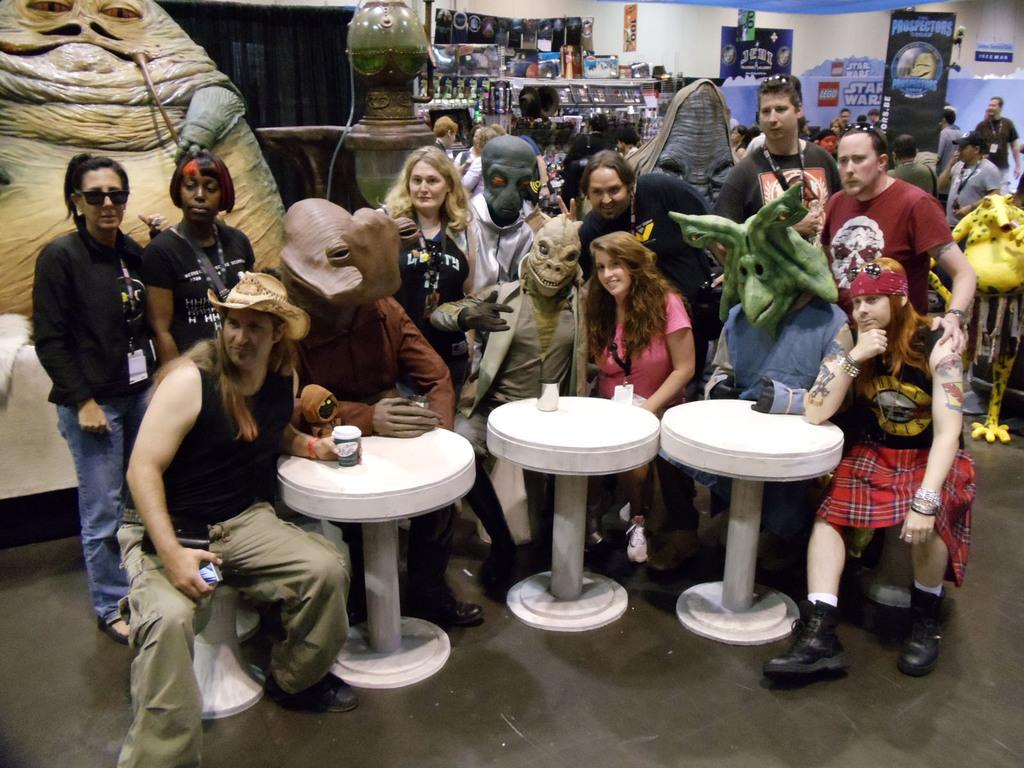What are the people in the image doing? The people in the image are posing for a photo. Can you describe the setting of the image? There is a group of people in the background of the image. What invention can be seen in the image? There is no specific invention visible in the image; it primarily features people posing for a photo. 